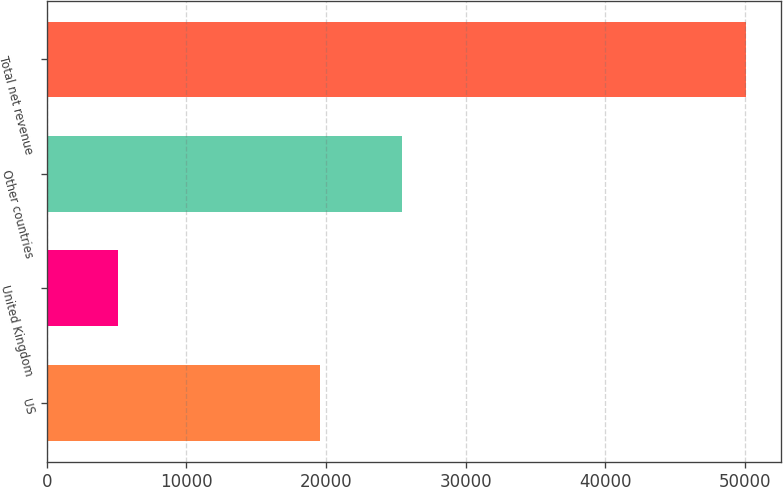<chart> <loc_0><loc_0><loc_500><loc_500><bar_chart><fcel>US<fcel>United Kingdom<fcel>Other countries<fcel>Total net revenue<nl><fcel>19581<fcel>5074<fcel>25468<fcel>50123<nl></chart> 